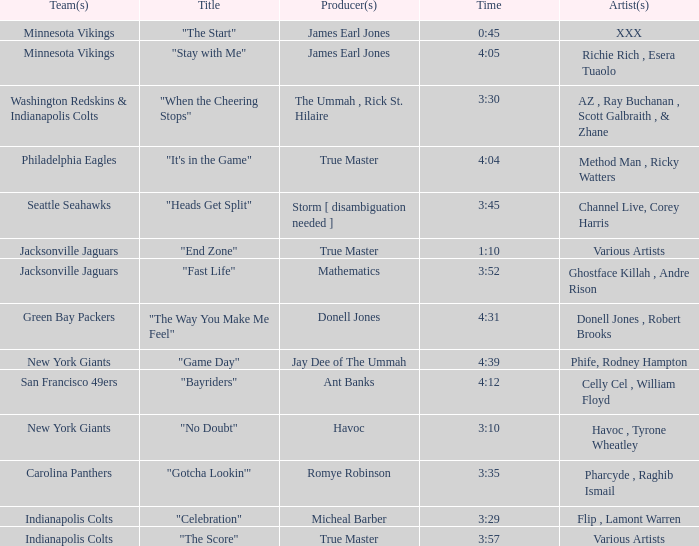Who produced "Fast Life"? Mathematics. 